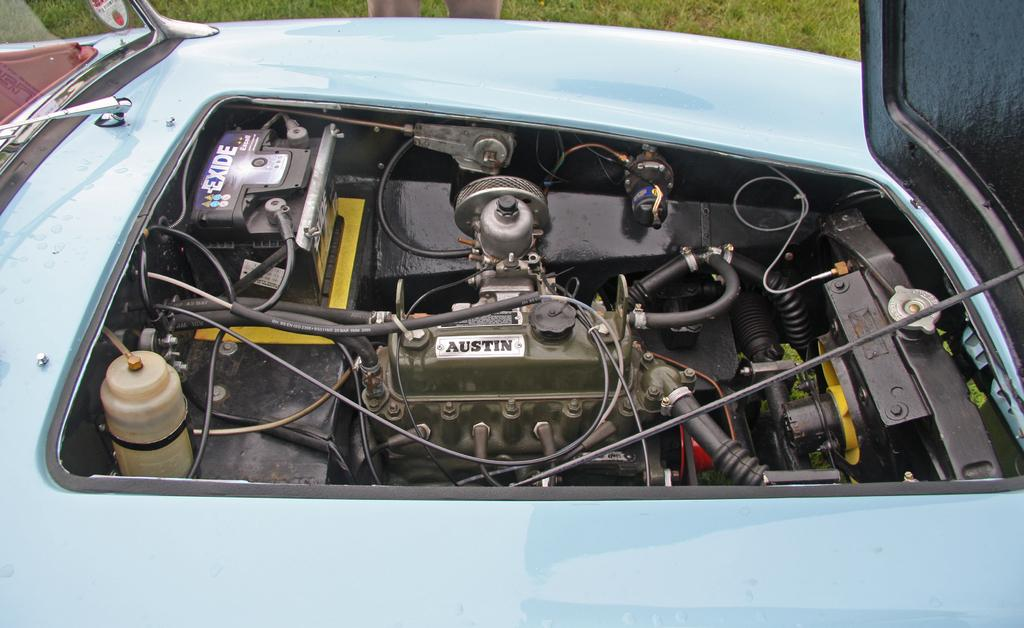What is the main subject of the image? There is a car in the image. Can you describe any specific parts of the car that are visible? A vehicle part of the car is visible in the image. Is there any indication of a person in the image? Yes, a person's leg is visible at the top of the image. What invention is being demonstrated by the person in the image? There is no invention being demonstrated in the image; it only shows a car and a person's leg. Can you tell me how many stations are visible in the image? There are no stations present in the image. 